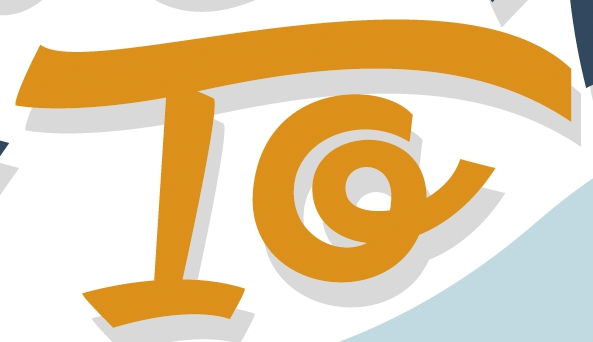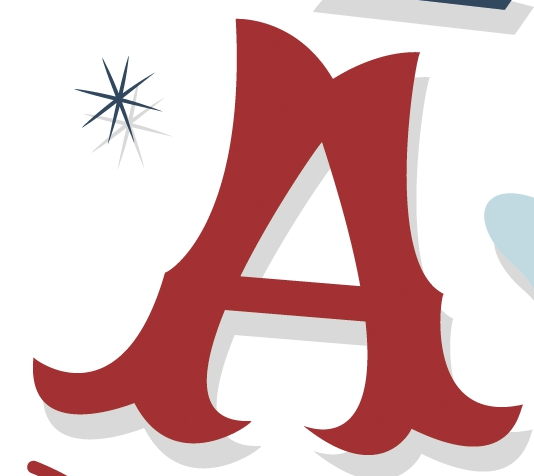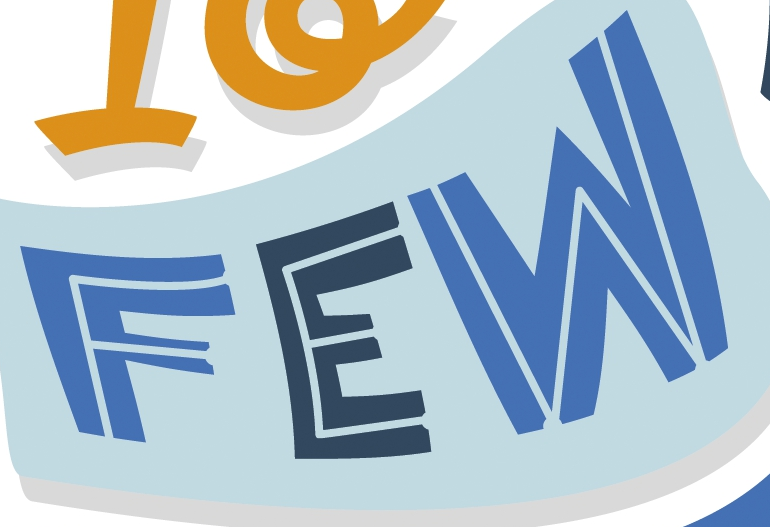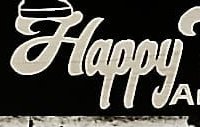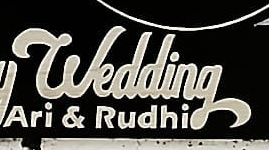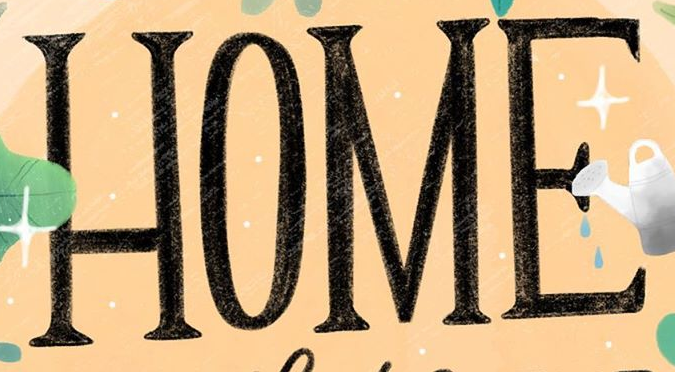What text appears in these images from left to right, separated by a semicolon? To; A; FEW; Happy; wedding; HOME 